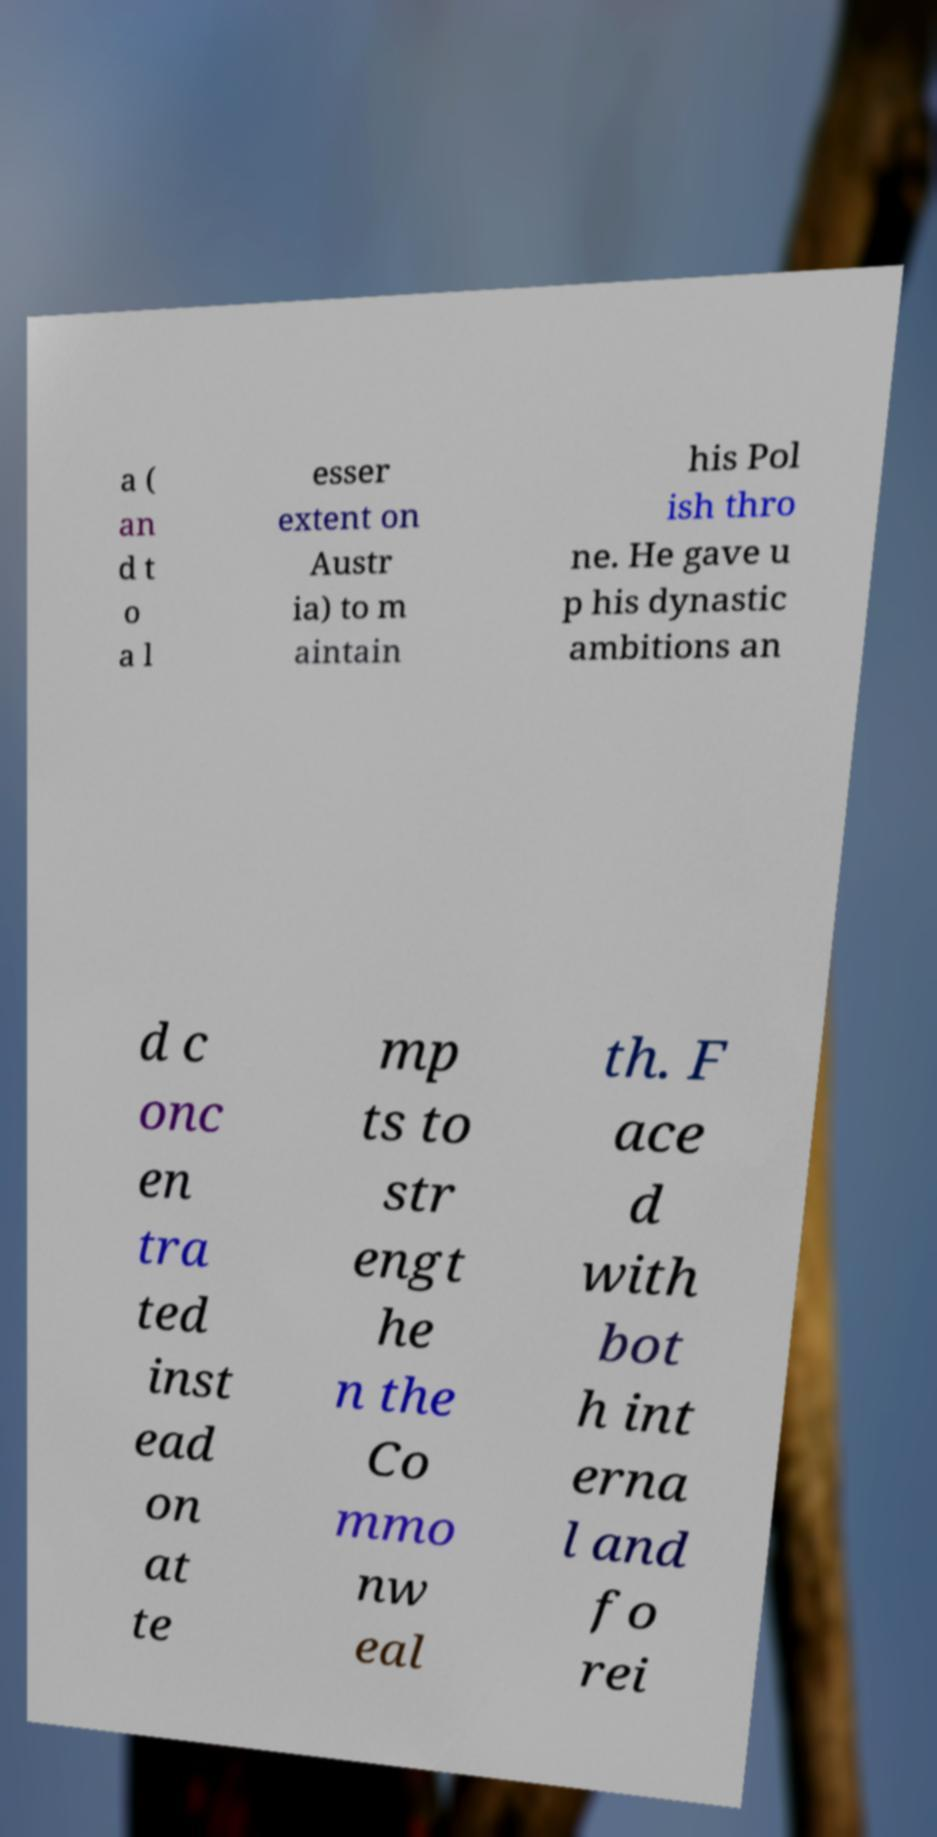For documentation purposes, I need the text within this image transcribed. Could you provide that? a ( an d t o a l esser extent on Austr ia) to m aintain his Pol ish thro ne. He gave u p his dynastic ambitions an d c onc en tra ted inst ead on at te mp ts to str engt he n the Co mmo nw eal th. F ace d with bot h int erna l and fo rei 